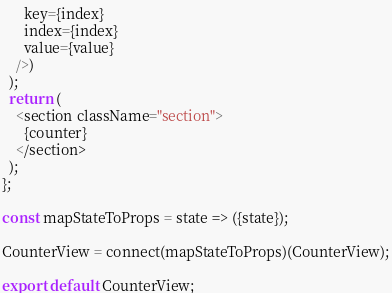Convert code to text. <code><loc_0><loc_0><loc_500><loc_500><_JavaScript_>      key={index}
      index={index}
      value={value}
    />)
  );
  return (
    <section className="section">
      {counter}
    </section>
  );
};

const mapStateToProps = state => ({state});

CounterView = connect(mapStateToProps)(CounterView);

export default CounterView;
</code> 